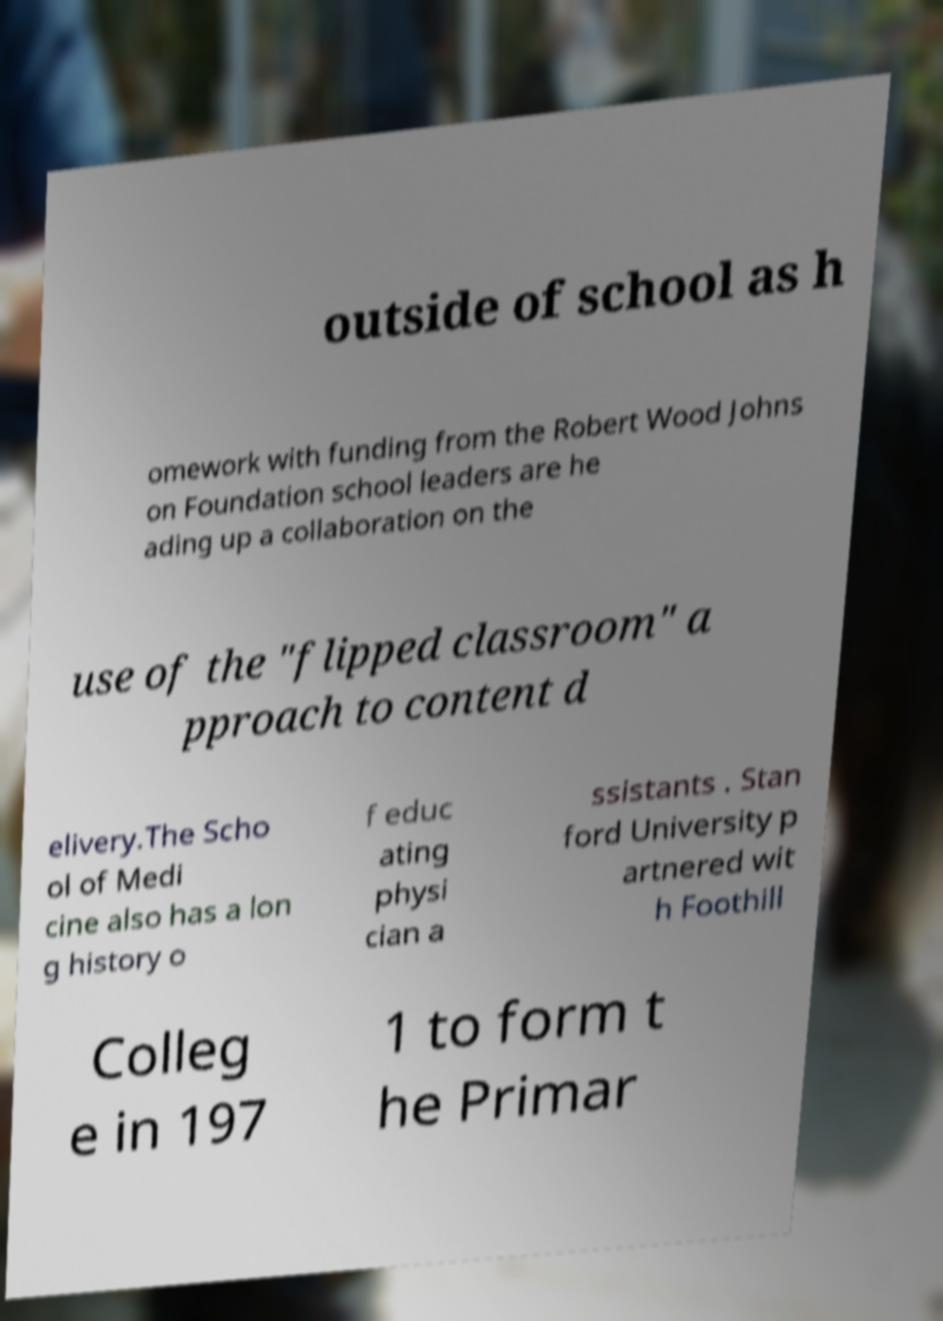Please identify and transcribe the text found in this image. outside of school as h omework with funding from the Robert Wood Johns on Foundation school leaders are he ading up a collaboration on the use of the "flipped classroom" a pproach to content d elivery.The Scho ol of Medi cine also has a lon g history o f educ ating physi cian a ssistants . Stan ford University p artnered wit h Foothill Colleg e in 197 1 to form t he Primar 